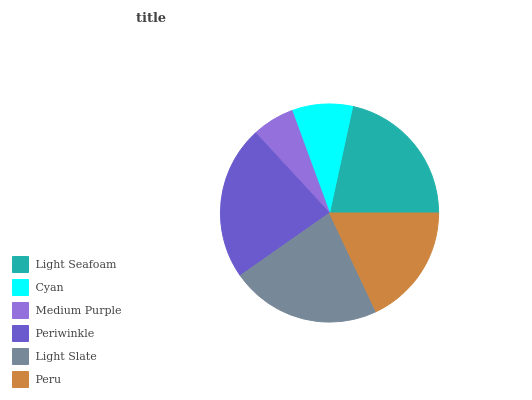Is Medium Purple the minimum?
Answer yes or no. Yes. Is Periwinkle the maximum?
Answer yes or no. Yes. Is Cyan the minimum?
Answer yes or no. No. Is Cyan the maximum?
Answer yes or no. No. Is Light Seafoam greater than Cyan?
Answer yes or no. Yes. Is Cyan less than Light Seafoam?
Answer yes or no. Yes. Is Cyan greater than Light Seafoam?
Answer yes or no. No. Is Light Seafoam less than Cyan?
Answer yes or no. No. Is Light Seafoam the high median?
Answer yes or no. Yes. Is Peru the low median?
Answer yes or no. Yes. Is Light Slate the high median?
Answer yes or no. No. Is Periwinkle the low median?
Answer yes or no. No. 